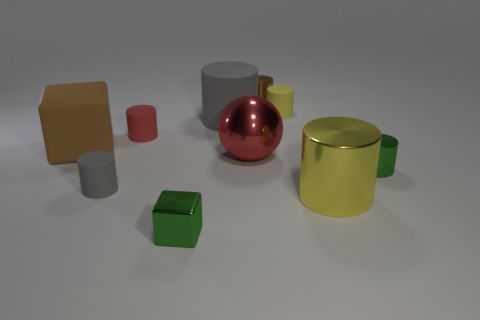The green cylinder that is the same material as the sphere is what size?
Ensure brevity in your answer.  Small. What number of things are either big things that are to the left of the red ball or large red metal things?
Offer a terse response. 3. Do the block that is in front of the big block and the matte block have the same color?
Your answer should be very brief. No. There is a red thing that is the same shape as the big yellow shiny thing; what size is it?
Offer a terse response. Small. There is a tiny thing behind the yellow thing behind the large object behind the brown matte object; what color is it?
Give a very brief answer. Brown. Do the red sphere and the green cube have the same material?
Offer a terse response. Yes. Is there a big red shiny thing that is right of the green thing that is in front of the gray matte object that is to the left of the big matte cylinder?
Provide a short and direct response. Yes. Does the tiny cube have the same color as the big matte cylinder?
Give a very brief answer. No. Are there fewer big brown things than tiny blue shiny things?
Ensure brevity in your answer.  No. Are the gray cylinder that is behind the large red object and the large thing left of the big rubber cylinder made of the same material?
Offer a very short reply. Yes. 